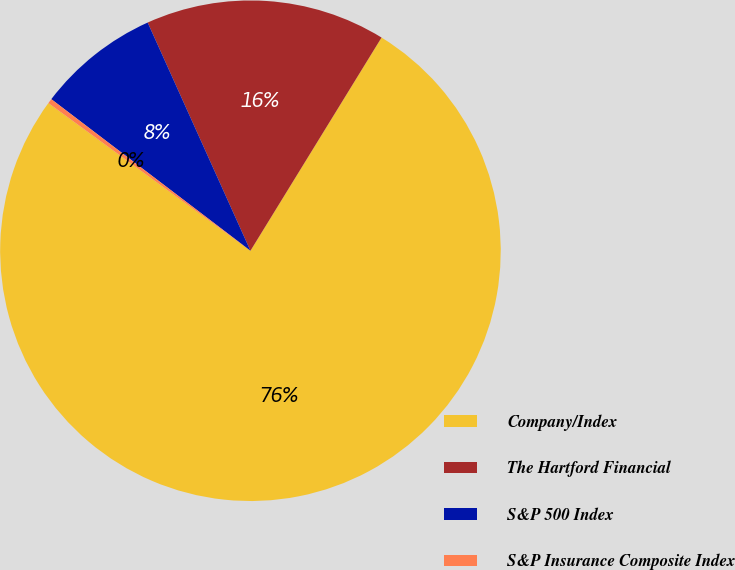Convert chart to OTSL. <chart><loc_0><loc_0><loc_500><loc_500><pie_chart><fcel>Company/Index<fcel>The Hartford Financial<fcel>S&P 500 Index<fcel>S&P Insurance Composite Index<nl><fcel>76.27%<fcel>15.51%<fcel>7.91%<fcel>0.31%<nl></chart> 